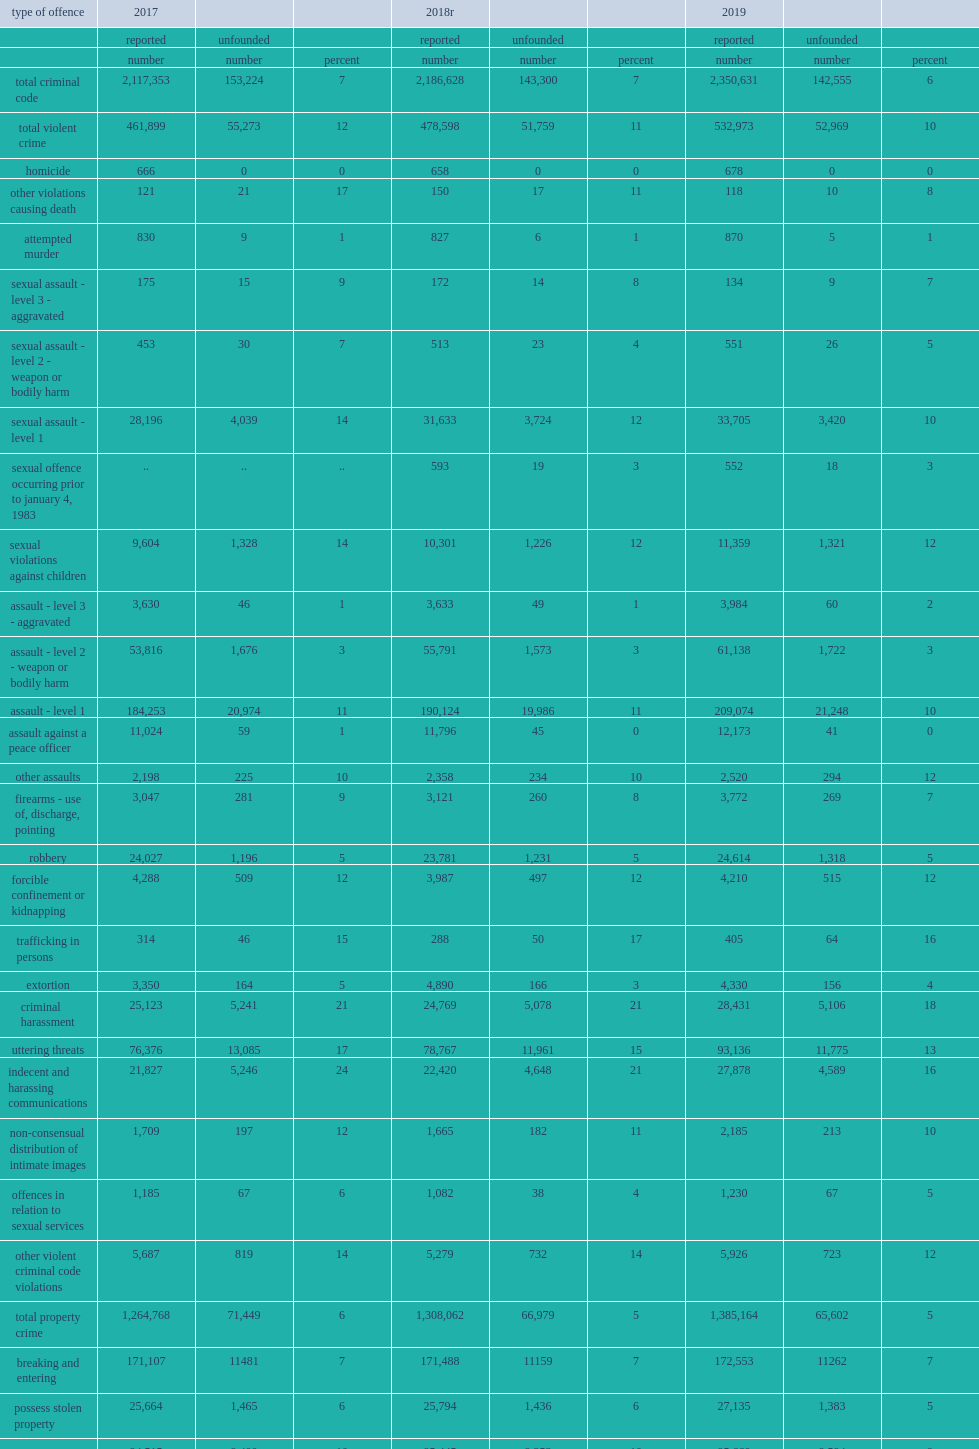What was the proportion of common physical assault (level 1) classified as unfounded dropped from in 2017? 11.0. What was the proportion of common physical assault (level 1) classified as unfounded dropped to in 2019? 10.0. 